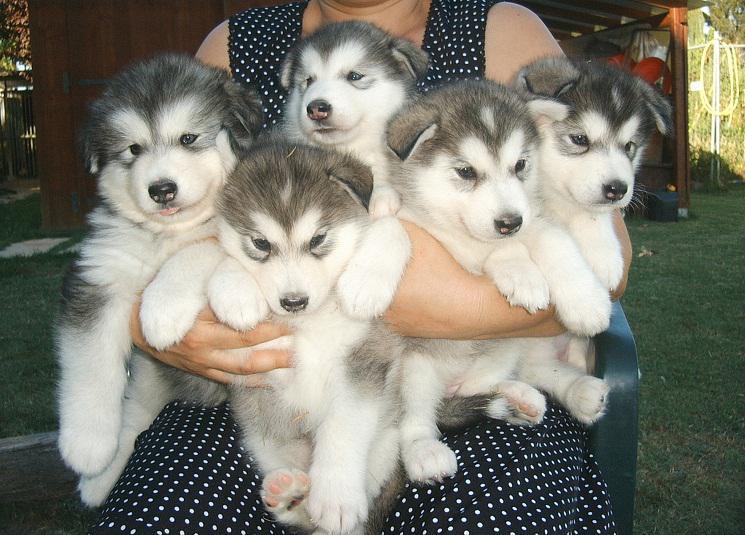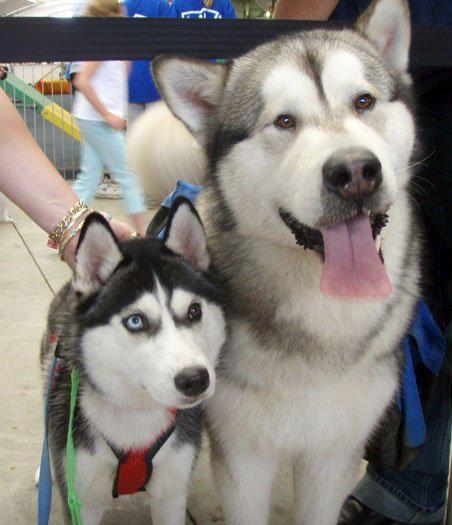The first image is the image on the left, the second image is the image on the right. Examine the images to the left and right. Is the description "One of the images contains two dogs with their mouths open." accurate? Answer yes or no. No. The first image is the image on the left, the second image is the image on the right. Considering the images on both sides, is "There are five grey headed husky puppies next to each other." valid? Answer yes or no. Yes. 